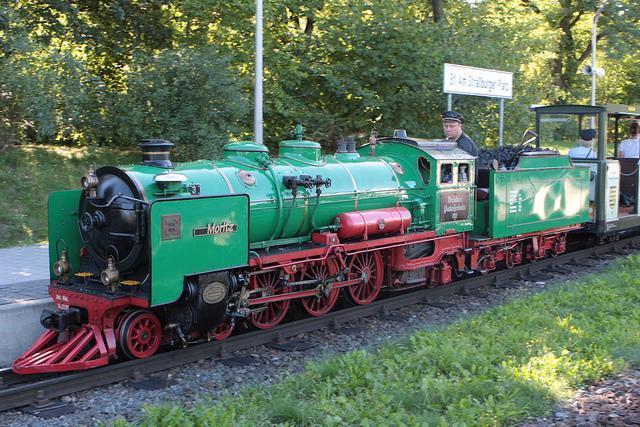How many yellow taxi cars are in this image?
Give a very brief answer. 0. 